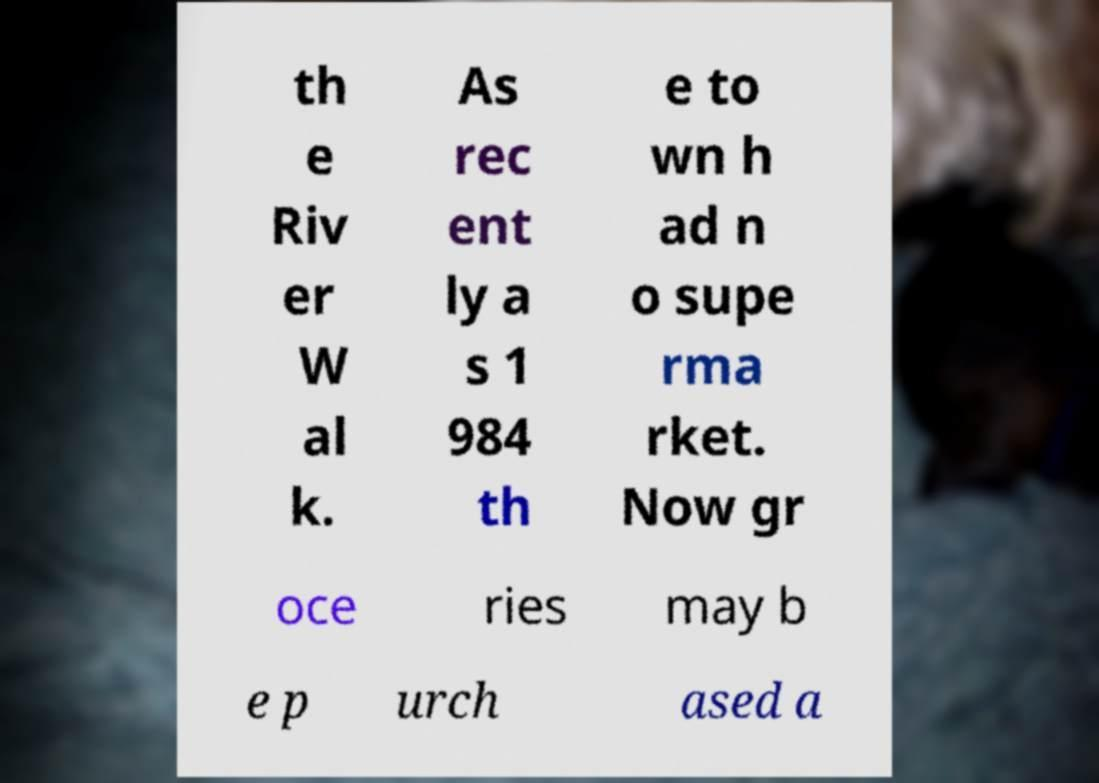Can you accurately transcribe the text from the provided image for me? th e Riv er W al k. As rec ent ly a s 1 984 th e to wn h ad n o supe rma rket. Now gr oce ries may b e p urch ased a 